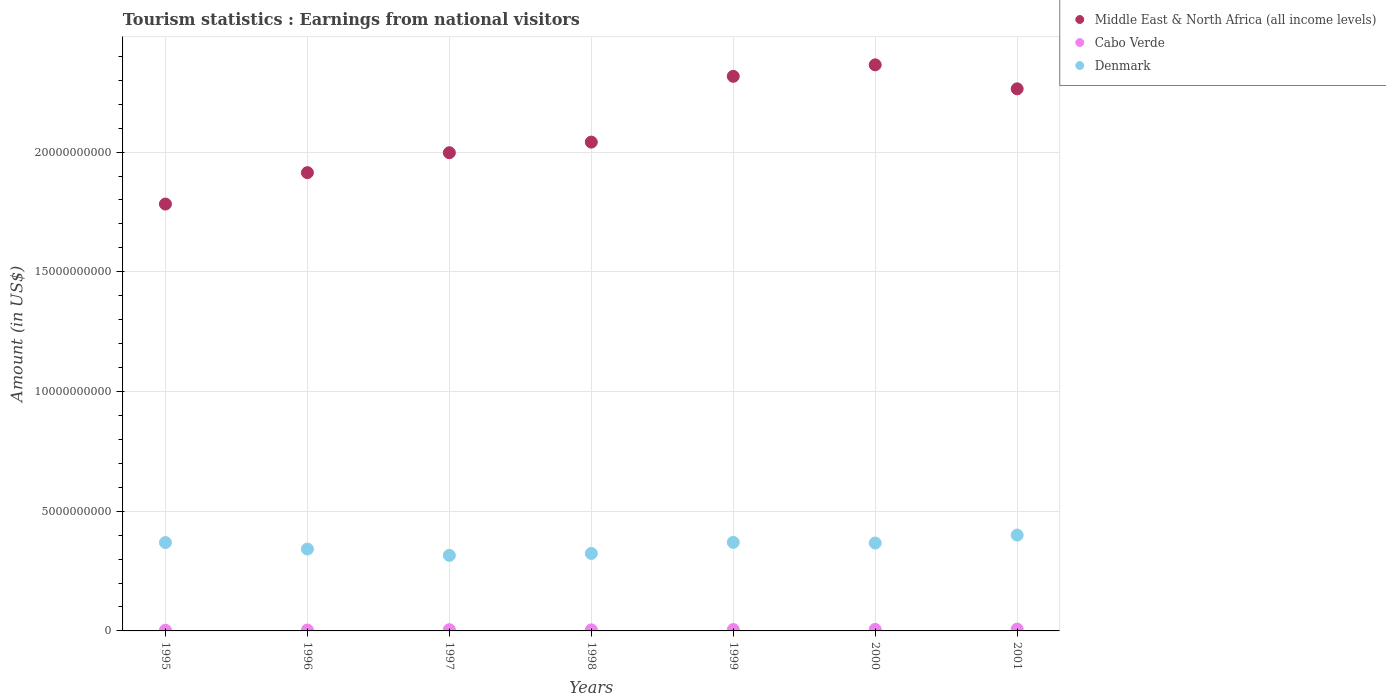How many different coloured dotlines are there?
Give a very brief answer. 3. Is the number of dotlines equal to the number of legend labels?
Your answer should be very brief. Yes. What is the earnings from national visitors in Denmark in 1996?
Offer a terse response. 3.42e+09. Across all years, what is the maximum earnings from national visitors in Cabo Verde?
Keep it short and to the point. 7.70e+07. Across all years, what is the minimum earnings from national visitors in Cabo Verde?
Your response must be concise. 2.90e+07. In which year was the earnings from national visitors in Cabo Verde minimum?
Your answer should be compact. 1995. What is the total earnings from national visitors in Cabo Verde in the graph?
Provide a short and direct response. 3.58e+08. What is the difference between the earnings from national visitors in Denmark in 1999 and that in 2000?
Your response must be concise. 2.70e+07. What is the difference between the earnings from national visitors in Cabo Verde in 1995 and the earnings from national visitors in Denmark in 2000?
Provide a succinct answer. -3.64e+09. What is the average earnings from national visitors in Denmark per year?
Your answer should be very brief. 3.55e+09. In the year 2001, what is the difference between the earnings from national visitors in Denmark and earnings from national visitors in Cabo Verde?
Your answer should be compact. 3.93e+09. What is the ratio of the earnings from national visitors in Cabo Verde in 1996 to that in 1998?
Provide a short and direct response. 0.82. Is the earnings from national visitors in Denmark in 1998 less than that in 1999?
Your answer should be very brief. Yes. What is the difference between the highest and the second highest earnings from national visitors in Denmark?
Your answer should be compact. 3.05e+08. What is the difference between the highest and the lowest earnings from national visitors in Cabo Verde?
Ensure brevity in your answer.  4.80e+07. Is it the case that in every year, the sum of the earnings from national visitors in Cabo Verde and earnings from national visitors in Middle East & North Africa (all income levels)  is greater than the earnings from national visitors in Denmark?
Offer a very short reply. Yes. Is the earnings from national visitors in Cabo Verde strictly less than the earnings from national visitors in Denmark over the years?
Make the answer very short. Yes. How many dotlines are there?
Ensure brevity in your answer.  3. How many years are there in the graph?
Make the answer very short. 7. Are the values on the major ticks of Y-axis written in scientific E-notation?
Ensure brevity in your answer.  No. What is the title of the graph?
Provide a succinct answer. Tourism statistics : Earnings from national visitors. Does "Trinidad and Tobago" appear as one of the legend labels in the graph?
Provide a short and direct response. No. What is the Amount (in US$) of Middle East & North Africa (all income levels) in 1995?
Offer a very short reply. 1.78e+1. What is the Amount (in US$) in Cabo Verde in 1995?
Provide a succinct answer. 2.90e+07. What is the Amount (in US$) of Denmark in 1995?
Make the answer very short. 3.69e+09. What is the Amount (in US$) in Middle East & North Africa (all income levels) in 1996?
Your answer should be compact. 1.91e+1. What is the Amount (in US$) of Cabo Verde in 1996?
Your answer should be very brief. 3.70e+07. What is the Amount (in US$) in Denmark in 1996?
Provide a succinct answer. 3.42e+09. What is the Amount (in US$) in Middle East & North Africa (all income levels) in 1997?
Your answer should be very brief. 2.00e+1. What is the Amount (in US$) in Cabo Verde in 1997?
Your answer should be very brief. 5.00e+07. What is the Amount (in US$) in Denmark in 1997?
Ensure brevity in your answer.  3.16e+09. What is the Amount (in US$) of Middle East & North Africa (all income levels) in 1998?
Offer a very short reply. 2.04e+1. What is the Amount (in US$) of Cabo Verde in 1998?
Keep it short and to the point. 4.50e+07. What is the Amount (in US$) in Denmark in 1998?
Provide a short and direct response. 3.24e+09. What is the Amount (in US$) in Middle East & North Africa (all income levels) in 1999?
Offer a terse response. 2.32e+1. What is the Amount (in US$) of Cabo Verde in 1999?
Offer a very short reply. 5.60e+07. What is the Amount (in US$) of Denmark in 1999?
Provide a succinct answer. 3.70e+09. What is the Amount (in US$) of Middle East & North Africa (all income levels) in 2000?
Offer a very short reply. 2.36e+1. What is the Amount (in US$) in Cabo Verde in 2000?
Offer a terse response. 6.40e+07. What is the Amount (in US$) of Denmark in 2000?
Make the answer very short. 3.67e+09. What is the Amount (in US$) in Middle East & North Africa (all income levels) in 2001?
Keep it short and to the point. 2.26e+1. What is the Amount (in US$) of Cabo Verde in 2001?
Give a very brief answer. 7.70e+07. What is the Amount (in US$) in Denmark in 2001?
Make the answer very short. 4.00e+09. Across all years, what is the maximum Amount (in US$) of Middle East & North Africa (all income levels)?
Give a very brief answer. 2.36e+1. Across all years, what is the maximum Amount (in US$) in Cabo Verde?
Give a very brief answer. 7.70e+07. Across all years, what is the maximum Amount (in US$) of Denmark?
Provide a short and direct response. 4.00e+09. Across all years, what is the minimum Amount (in US$) of Middle East & North Africa (all income levels)?
Your answer should be compact. 1.78e+1. Across all years, what is the minimum Amount (in US$) in Cabo Verde?
Your response must be concise. 2.90e+07. Across all years, what is the minimum Amount (in US$) of Denmark?
Make the answer very short. 3.16e+09. What is the total Amount (in US$) of Middle East & North Africa (all income levels) in the graph?
Provide a short and direct response. 1.47e+11. What is the total Amount (in US$) in Cabo Verde in the graph?
Keep it short and to the point. 3.58e+08. What is the total Amount (in US$) of Denmark in the graph?
Your answer should be very brief. 2.49e+1. What is the difference between the Amount (in US$) of Middle East & North Africa (all income levels) in 1995 and that in 1996?
Give a very brief answer. -1.31e+09. What is the difference between the Amount (in US$) of Cabo Verde in 1995 and that in 1996?
Provide a short and direct response. -8.00e+06. What is the difference between the Amount (in US$) of Denmark in 1995 and that in 1996?
Give a very brief answer. 2.71e+08. What is the difference between the Amount (in US$) in Middle East & North Africa (all income levels) in 1995 and that in 1997?
Your answer should be very brief. -2.14e+09. What is the difference between the Amount (in US$) in Cabo Verde in 1995 and that in 1997?
Offer a very short reply. -2.10e+07. What is the difference between the Amount (in US$) of Denmark in 1995 and that in 1997?
Give a very brief answer. 5.35e+08. What is the difference between the Amount (in US$) in Middle East & North Africa (all income levels) in 1995 and that in 1998?
Keep it short and to the point. -2.59e+09. What is the difference between the Amount (in US$) of Cabo Verde in 1995 and that in 1998?
Offer a very short reply. -1.60e+07. What is the difference between the Amount (in US$) in Denmark in 1995 and that in 1998?
Offer a very short reply. 4.55e+08. What is the difference between the Amount (in US$) of Middle East & North Africa (all income levels) in 1995 and that in 1999?
Provide a succinct answer. -5.34e+09. What is the difference between the Amount (in US$) in Cabo Verde in 1995 and that in 1999?
Give a very brief answer. -2.70e+07. What is the difference between the Amount (in US$) of Denmark in 1995 and that in 1999?
Ensure brevity in your answer.  -7.00e+06. What is the difference between the Amount (in US$) in Middle East & North Africa (all income levels) in 1995 and that in 2000?
Make the answer very short. -5.81e+09. What is the difference between the Amount (in US$) in Cabo Verde in 1995 and that in 2000?
Your answer should be very brief. -3.50e+07. What is the difference between the Amount (in US$) in Denmark in 1995 and that in 2000?
Provide a short and direct response. 2.00e+07. What is the difference between the Amount (in US$) in Middle East & North Africa (all income levels) in 1995 and that in 2001?
Ensure brevity in your answer.  -4.81e+09. What is the difference between the Amount (in US$) in Cabo Verde in 1995 and that in 2001?
Provide a succinct answer. -4.80e+07. What is the difference between the Amount (in US$) of Denmark in 1995 and that in 2001?
Offer a very short reply. -3.12e+08. What is the difference between the Amount (in US$) in Middle East & North Africa (all income levels) in 1996 and that in 1997?
Ensure brevity in your answer.  -8.33e+08. What is the difference between the Amount (in US$) in Cabo Verde in 1996 and that in 1997?
Provide a succinct answer. -1.30e+07. What is the difference between the Amount (in US$) in Denmark in 1996 and that in 1997?
Offer a terse response. 2.64e+08. What is the difference between the Amount (in US$) in Middle East & North Africa (all income levels) in 1996 and that in 1998?
Your response must be concise. -1.28e+09. What is the difference between the Amount (in US$) in Cabo Verde in 1996 and that in 1998?
Offer a very short reply. -8.00e+06. What is the difference between the Amount (in US$) in Denmark in 1996 and that in 1998?
Ensure brevity in your answer.  1.84e+08. What is the difference between the Amount (in US$) in Middle East & North Africa (all income levels) in 1996 and that in 1999?
Offer a very short reply. -4.02e+09. What is the difference between the Amount (in US$) in Cabo Verde in 1996 and that in 1999?
Keep it short and to the point. -1.90e+07. What is the difference between the Amount (in US$) of Denmark in 1996 and that in 1999?
Offer a terse response. -2.78e+08. What is the difference between the Amount (in US$) in Middle East & North Africa (all income levels) in 1996 and that in 2000?
Your answer should be very brief. -4.50e+09. What is the difference between the Amount (in US$) of Cabo Verde in 1996 and that in 2000?
Keep it short and to the point. -2.70e+07. What is the difference between the Amount (in US$) of Denmark in 1996 and that in 2000?
Provide a short and direct response. -2.51e+08. What is the difference between the Amount (in US$) in Middle East & North Africa (all income levels) in 1996 and that in 2001?
Offer a very short reply. -3.50e+09. What is the difference between the Amount (in US$) of Cabo Verde in 1996 and that in 2001?
Your response must be concise. -4.00e+07. What is the difference between the Amount (in US$) in Denmark in 1996 and that in 2001?
Your response must be concise. -5.83e+08. What is the difference between the Amount (in US$) in Middle East & North Africa (all income levels) in 1997 and that in 1998?
Make the answer very short. -4.43e+08. What is the difference between the Amount (in US$) of Denmark in 1997 and that in 1998?
Give a very brief answer. -8.00e+07. What is the difference between the Amount (in US$) in Middle East & North Africa (all income levels) in 1997 and that in 1999?
Provide a succinct answer. -3.19e+09. What is the difference between the Amount (in US$) of Cabo Verde in 1997 and that in 1999?
Your answer should be compact. -6.00e+06. What is the difference between the Amount (in US$) of Denmark in 1997 and that in 1999?
Offer a terse response. -5.42e+08. What is the difference between the Amount (in US$) in Middle East & North Africa (all income levels) in 1997 and that in 2000?
Offer a terse response. -3.67e+09. What is the difference between the Amount (in US$) in Cabo Verde in 1997 and that in 2000?
Provide a succinct answer. -1.40e+07. What is the difference between the Amount (in US$) in Denmark in 1997 and that in 2000?
Provide a short and direct response. -5.15e+08. What is the difference between the Amount (in US$) in Middle East & North Africa (all income levels) in 1997 and that in 2001?
Ensure brevity in your answer.  -2.67e+09. What is the difference between the Amount (in US$) of Cabo Verde in 1997 and that in 2001?
Your response must be concise. -2.70e+07. What is the difference between the Amount (in US$) of Denmark in 1997 and that in 2001?
Give a very brief answer. -8.47e+08. What is the difference between the Amount (in US$) of Middle East & North Africa (all income levels) in 1998 and that in 1999?
Provide a short and direct response. -2.75e+09. What is the difference between the Amount (in US$) of Cabo Verde in 1998 and that in 1999?
Your answer should be very brief. -1.10e+07. What is the difference between the Amount (in US$) of Denmark in 1998 and that in 1999?
Make the answer very short. -4.62e+08. What is the difference between the Amount (in US$) of Middle East & North Africa (all income levels) in 1998 and that in 2000?
Offer a very short reply. -3.23e+09. What is the difference between the Amount (in US$) of Cabo Verde in 1998 and that in 2000?
Keep it short and to the point. -1.90e+07. What is the difference between the Amount (in US$) of Denmark in 1998 and that in 2000?
Your answer should be very brief. -4.35e+08. What is the difference between the Amount (in US$) of Middle East & North Africa (all income levels) in 1998 and that in 2001?
Offer a terse response. -2.22e+09. What is the difference between the Amount (in US$) of Cabo Verde in 1998 and that in 2001?
Provide a short and direct response. -3.20e+07. What is the difference between the Amount (in US$) in Denmark in 1998 and that in 2001?
Make the answer very short. -7.67e+08. What is the difference between the Amount (in US$) of Middle East & North Africa (all income levels) in 1999 and that in 2000?
Offer a very short reply. -4.79e+08. What is the difference between the Amount (in US$) in Cabo Verde in 1999 and that in 2000?
Give a very brief answer. -8.00e+06. What is the difference between the Amount (in US$) in Denmark in 1999 and that in 2000?
Make the answer very short. 2.70e+07. What is the difference between the Amount (in US$) of Middle East & North Africa (all income levels) in 1999 and that in 2001?
Your answer should be compact. 5.23e+08. What is the difference between the Amount (in US$) of Cabo Verde in 1999 and that in 2001?
Provide a succinct answer. -2.10e+07. What is the difference between the Amount (in US$) in Denmark in 1999 and that in 2001?
Give a very brief answer. -3.05e+08. What is the difference between the Amount (in US$) of Middle East & North Africa (all income levels) in 2000 and that in 2001?
Provide a succinct answer. 1.00e+09. What is the difference between the Amount (in US$) of Cabo Verde in 2000 and that in 2001?
Keep it short and to the point. -1.30e+07. What is the difference between the Amount (in US$) in Denmark in 2000 and that in 2001?
Your response must be concise. -3.32e+08. What is the difference between the Amount (in US$) in Middle East & North Africa (all income levels) in 1995 and the Amount (in US$) in Cabo Verde in 1996?
Offer a very short reply. 1.78e+1. What is the difference between the Amount (in US$) in Middle East & North Africa (all income levels) in 1995 and the Amount (in US$) in Denmark in 1996?
Make the answer very short. 1.44e+1. What is the difference between the Amount (in US$) of Cabo Verde in 1995 and the Amount (in US$) of Denmark in 1996?
Offer a terse response. -3.39e+09. What is the difference between the Amount (in US$) in Middle East & North Africa (all income levels) in 1995 and the Amount (in US$) in Cabo Verde in 1997?
Give a very brief answer. 1.78e+1. What is the difference between the Amount (in US$) of Middle East & North Africa (all income levels) in 1995 and the Amount (in US$) of Denmark in 1997?
Provide a short and direct response. 1.47e+1. What is the difference between the Amount (in US$) in Cabo Verde in 1995 and the Amount (in US$) in Denmark in 1997?
Your answer should be compact. -3.13e+09. What is the difference between the Amount (in US$) of Middle East & North Africa (all income levels) in 1995 and the Amount (in US$) of Cabo Verde in 1998?
Offer a terse response. 1.78e+1. What is the difference between the Amount (in US$) in Middle East & North Africa (all income levels) in 1995 and the Amount (in US$) in Denmark in 1998?
Offer a very short reply. 1.46e+1. What is the difference between the Amount (in US$) in Cabo Verde in 1995 and the Amount (in US$) in Denmark in 1998?
Your answer should be very brief. -3.21e+09. What is the difference between the Amount (in US$) in Middle East & North Africa (all income levels) in 1995 and the Amount (in US$) in Cabo Verde in 1999?
Keep it short and to the point. 1.78e+1. What is the difference between the Amount (in US$) in Middle East & North Africa (all income levels) in 1995 and the Amount (in US$) in Denmark in 1999?
Keep it short and to the point. 1.41e+1. What is the difference between the Amount (in US$) of Cabo Verde in 1995 and the Amount (in US$) of Denmark in 1999?
Make the answer very short. -3.67e+09. What is the difference between the Amount (in US$) of Middle East & North Africa (all income levels) in 1995 and the Amount (in US$) of Cabo Verde in 2000?
Keep it short and to the point. 1.78e+1. What is the difference between the Amount (in US$) in Middle East & North Africa (all income levels) in 1995 and the Amount (in US$) in Denmark in 2000?
Make the answer very short. 1.42e+1. What is the difference between the Amount (in US$) of Cabo Verde in 1995 and the Amount (in US$) of Denmark in 2000?
Your answer should be compact. -3.64e+09. What is the difference between the Amount (in US$) of Middle East & North Africa (all income levels) in 1995 and the Amount (in US$) of Cabo Verde in 2001?
Your response must be concise. 1.78e+1. What is the difference between the Amount (in US$) in Middle East & North Africa (all income levels) in 1995 and the Amount (in US$) in Denmark in 2001?
Provide a succinct answer. 1.38e+1. What is the difference between the Amount (in US$) in Cabo Verde in 1995 and the Amount (in US$) in Denmark in 2001?
Your answer should be very brief. -3.97e+09. What is the difference between the Amount (in US$) of Middle East & North Africa (all income levels) in 1996 and the Amount (in US$) of Cabo Verde in 1997?
Make the answer very short. 1.91e+1. What is the difference between the Amount (in US$) of Middle East & North Africa (all income levels) in 1996 and the Amount (in US$) of Denmark in 1997?
Your answer should be very brief. 1.60e+1. What is the difference between the Amount (in US$) of Cabo Verde in 1996 and the Amount (in US$) of Denmark in 1997?
Make the answer very short. -3.12e+09. What is the difference between the Amount (in US$) in Middle East & North Africa (all income levels) in 1996 and the Amount (in US$) in Cabo Verde in 1998?
Make the answer very short. 1.91e+1. What is the difference between the Amount (in US$) in Middle East & North Africa (all income levels) in 1996 and the Amount (in US$) in Denmark in 1998?
Give a very brief answer. 1.59e+1. What is the difference between the Amount (in US$) of Cabo Verde in 1996 and the Amount (in US$) of Denmark in 1998?
Your answer should be very brief. -3.20e+09. What is the difference between the Amount (in US$) in Middle East & North Africa (all income levels) in 1996 and the Amount (in US$) in Cabo Verde in 1999?
Keep it short and to the point. 1.91e+1. What is the difference between the Amount (in US$) in Middle East & North Africa (all income levels) in 1996 and the Amount (in US$) in Denmark in 1999?
Your answer should be compact. 1.54e+1. What is the difference between the Amount (in US$) in Cabo Verde in 1996 and the Amount (in US$) in Denmark in 1999?
Offer a very short reply. -3.66e+09. What is the difference between the Amount (in US$) of Middle East & North Africa (all income levels) in 1996 and the Amount (in US$) of Cabo Verde in 2000?
Your answer should be very brief. 1.91e+1. What is the difference between the Amount (in US$) in Middle East & North Africa (all income levels) in 1996 and the Amount (in US$) in Denmark in 2000?
Provide a short and direct response. 1.55e+1. What is the difference between the Amount (in US$) of Cabo Verde in 1996 and the Amount (in US$) of Denmark in 2000?
Your response must be concise. -3.63e+09. What is the difference between the Amount (in US$) of Middle East & North Africa (all income levels) in 1996 and the Amount (in US$) of Cabo Verde in 2001?
Keep it short and to the point. 1.91e+1. What is the difference between the Amount (in US$) in Middle East & North Africa (all income levels) in 1996 and the Amount (in US$) in Denmark in 2001?
Provide a short and direct response. 1.51e+1. What is the difference between the Amount (in US$) in Cabo Verde in 1996 and the Amount (in US$) in Denmark in 2001?
Your answer should be very brief. -3.97e+09. What is the difference between the Amount (in US$) of Middle East & North Africa (all income levels) in 1997 and the Amount (in US$) of Cabo Verde in 1998?
Offer a terse response. 1.99e+1. What is the difference between the Amount (in US$) in Middle East & North Africa (all income levels) in 1997 and the Amount (in US$) in Denmark in 1998?
Provide a succinct answer. 1.67e+1. What is the difference between the Amount (in US$) in Cabo Verde in 1997 and the Amount (in US$) in Denmark in 1998?
Offer a terse response. -3.19e+09. What is the difference between the Amount (in US$) in Middle East & North Africa (all income levels) in 1997 and the Amount (in US$) in Cabo Verde in 1999?
Provide a succinct answer. 1.99e+1. What is the difference between the Amount (in US$) of Middle East & North Africa (all income levels) in 1997 and the Amount (in US$) of Denmark in 1999?
Provide a short and direct response. 1.63e+1. What is the difference between the Amount (in US$) in Cabo Verde in 1997 and the Amount (in US$) in Denmark in 1999?
Make the answer very short. -3.65e+09. What is the difference between the Amount (in US$) of Middle East & North Africa (all income levels) in 1997 and the Amount (in US$) of Cabo Verde in 2000?
Your answer should be compact. 1.99e+1. What is the difference between the Amount (in US$) of Middle East & North Africa (all income levels) in 1997 and the Amount (in US$) of Denmark in 2000?
Ensure brevity in your answer.  1.63e+1. What is the difference between the Amount (in US$) of Cabo Verde in 1997 and the Amount (in US$) of Denmark in 2000?
Offer a very short reply. -3.62e+09. What is the difference between the Amount (in US$) in Middle East & North Africa (all income levels) in 1997 and the Amount (in US$) in Cabo Verde in 2001?
Your answer should be compact. 1.99e+1. What is the difference between the Amount (in US$) of Middle East & North Africa (all income levels) in 1997 and the Amount (in US$) of Denmark in 2001?
Offer a terse response. 1.60e+1. What is the difference between the Amount (in US$) in Cabo Verde in 1997 and the Amount (in US$) in Denmark in 2001?
Your answer should be very brief. -3.95e+09. What is the difference between the Amount (in US$) of Middle East & North Africa (all income levels) in 1998 and the Amount (in US$) of Cabo Verde in 1999?
Your answer should be very brief. 2.04e+1. What is the difference between the Amount (in US$) of Middle East & North Africa (all income levels) in 1998 and the Amount (in US$) of Denmark in 1999?
Give a very brief answer. 1.67e+1. What is the difference between the Amount (in US$) in Cabo Verde in 1998 and the Amount (in US$) in Denmark in 1999?
Offer a very short reply. -3.65e+09. What is the difference between the Amount (in US$) of Middle East & North Africa (all income levels) in 1998 and the Amount (in US$) of Cabo Verde in 2000?
Your answer should be very brief. 2.04e+1. What is the difference between the Amount (in US$) in Middle East & North Africa (all income levels) in 1998 and the Amount (in US$) in Denmark in 2000?
Provide a short and direct response. 1.67e+1. What is the difference between the Amount (in US$) of Cabo Verde in 1998 and the Amount (in US$) of Denmark in 2000?
Your answer should be very brief. -3.63e+09. What is the difference between the Amount (in US$) of Middle East & North Africa (all income levels) in 1998 and the Amount (in US$) of Cabo Verde in 2001?
Offer a terse response. 2.03e+1. What is the difference between the Amount (in US$) of Middle East & North Africa (all income levels) in 1998 and the Amount (in US$) of Denmark in 2001?
Offer a terse response. 1.64e+1. What is the difference between the Amount (in US$) of Cabo Verde in 1998 and the Amount (in US$) of Denmark in 2001?
Your answer should be very brief. -3.96e+09. What is the difference between the Amount (in US$) of Middle East & North Africa (all income levels) in 1999 and the Amount (in US$) of Cabo Verde in 2000?
Your answer should be compact. 2.31e+1. What is the difference between the Amount (in US$) in Middle East & North Africa (all income levels) in 1999 and the Amount (in US$) in Denmark in 2000?
Your response must be concise. 1.95e+1. What is the difference between the Amount (in US$) in Cabo Verde in 1999 and the Amount (in US$) in Denmark in 2000?
Provide a succinct answer. -3.62e+09. What is the difference between the Amount (in US$) in Middle East & North Africa (all income levels) in 1999 and the Amount (in US$) in Cabo Verde in 2001?
Provide a succinct answer. 2.31e+1. What is the difference between the Amount (in US$) of Middle East & North Africa (all income levels) in 1999 and the Amount (in US$) of Denmark in 2001?
Offer a very short reply. 1.92e+1. What is the difference between the Amount (in US$) of Cabo Verde in 1999 and the Amount (in US$) of Denmark in 2001?
Your response must be concise. -3.95e+09. What is the difference between the Amount (in US$) of Middle East & North Africa (all income levels) in 2000 and the Amount (in US$) of Cabo Verde in 2001?
Your answer should be very brief. 2.36e+1. What is the difference between the Amount (in US$) in Middle East & North Africa (all income levels) in 2000 and the Amount (in US$) in Denmark in 2001?
Provide a short and direct response. 1.96e+1. What is the difference between the Amount (in US$) in Cabo Verde in 2000 and the Amount (in US$) in Denmark in 2001?
Ensure brevity in your answer.  -3.94e+09. What is the average Amount (in US$) of Middle East & North Africa (all income levels) per year?
Your answer should be very brief. 2.10e+1. What is the average Amount (in US$) in Cabo Verde per year?
Offer a terse response. 5.11e+07. What is the average Amount (in US$) of Denmark per year?
Your response must be concise. 3.55e+09. In the year 1995, what is the difference between the Amount (in US$) of Middle East & North Africa (all income levels) and Amount (in US$) of Cabo Verde?
Offer a very short reply. 1.78e+1. In the year 1995, what is the difference between the Amount (in US$) of Middle East & North Africa (all income levels) and Amount (in US$) of Denmark?
Keep it short and to the point. 1.41e+1. In the year 1995, what is the difference between the Amount (in US$) of Cabo Verde and Amount (in US$) of Denmark?
Your response must be concise. -3.66e+09. In the year 1996, what is the difference between the Amount (in US$) in Middle East & North Africa (all income levels) and Amount (in US$) in Cabo Verde?
Give a very brief answer. 1.91e+1. In the year 1996, what is the difference between the Amount (in US$) in Middle East & North Africa (all income levels) and Amount (in US$) in Denmark?
Provide a short and direct response. 1.57e+1. In the year 1996, what is the difference between the Amount (in US$) in Cabo Verde and Amount (in US$) in Denmark?
Provide a short and direct response. -3.38e+09. In the year 1997, what is the difference between the Amount (in US$) in Middle East & North Africa (all income levels) and Amount (in US$) in Cabo Verde?
Provide a short and direct response. 1.99e+1. In the year 1997, what is the difference between the Amount (in US$) of Middle East & North Africa (all income levels) and Amount (in US$) of Denmark?
Ensure brevity in your answer.  1.68e+1. In the year 1997, what is the difference between the Amount (in US$) of Cabo Verde and Amount (in US$) of Denmark?
Provide a short and direct response. -3.11e+09. In the year 1998, what is the difference between the Amount (in US$) of Middle East & North Africa (all income levels) and Amount (in US$) of Cabo Verde?
Provide a short and direct response. 2.04e+1. In the year 1998, what is the difference between the Amount (in US$) in Middle East & North Africa (all income levels) and Amount (in US$) in Denmark?
Provide a succinct answer. 1.72e+1. In the year 1998, what is the difference between the Amount (in US$) in Cabo Verde and Amount (in US$) in Denmark?
Give a very brief answer. -3.19e+09. In the year 1999, what is the difference between the Amount (in US$) in Middle East & North Africa (all income levels) and Amount (in US$) in Cabo Verde?
Your answer should be compact. 2.31e+1. In the year 1999, what is the difference between the Amount (in US$) of Middle East & North Africa (all income levels) and Amount (in US$) of Denmark?
Your answer should be very brief. 1.95e+1. In the year 1999, what is the difference between the Amount (in US$) in Cabo Verde and Amount (in US$) in Denmark?
Your answer should be very brief. -3.64e+09. In the year 2000, what is the difference between the Amount (in US$) in Middle East & North Africa (all income levels) and Amount (in US$) in Cabo Verde?
Make the answer very short. 2.36e+1. In the year 2000, what is the difference between the Amount (in US$) in Middle East & North Africa (all income levels) and Amount (in US$) in Denmark?
Offer a very short reply. 2.00e+1. In the year 2000, what is the difference between the Amount (in US$) in Cabo Verde and Amount (in US$) in Denmark?
Make the answer very short. -3.61e+09. In the year 2001, what is the difference between the Amount (in US$) in Middle East & North Africa (all income levels) and Amount (in US$) in Cabo Verde?
Offer a terse response. 2.26e+1. In the year 2001, what is the difference between the Amount (in US$) in Middle East & North Africa (all income levels) and Amount (in US$) in Denmark?
Your answer should be very brief. 1.86e+1. In the year 2001, what is the difference between the Amount (in US$) in Cabo Verde and Amount (in US$) in Denmark?
Offer a very short reply. -3.93e+09. What is the ratio of the Amount (in US$) of Middle East & North Africa (all income levels) in 1995 to that in 1996?
Keep it short and to the point. 0.93. What is the ratio of the Amount (in US$) in Cabo Verde in 1995 to that in 1996?
Offer a very short reply. 0.78. What is the ratio of the Amount (in US$) in Denmark in 1995 to that in 1996?
Give a very brief answer. 1.08. What is the ratio of the Amount (in US$) in Middle East & North Africa (all income levels) in 1995 to that in 1997?
Make the answer very short. 0.89. What is the ratio of the Amount (in US$) of Cabo Verde in 1995 to that in 1997?
Provide a succinct answer. 0.58. What is the ratio of the Amount (in US$) in Denmark in 1995 to that in 1997?
Your answer should be very brief. 1.17. What is the ratio of the Amount (in US$) of Middle East & North Africa (all income levels) in 1995 to that in 1998?
Your answer should be compact. 0.87. What is the ratio of the Amount (in US$) in Cabo Verde in 1995 to that in 1998?
Provide a short and direct response. 0.64. What is the ratio of the Amount (in US$) of Denmark in 1995 to that in 1998?
Your answer should be compact. 1.14. What is the ratio of the Amount (in US$) in Middle East & North Africa (all income levels) in 1995 to that in 1999?
Ensure brevity in your answer.  0.77. What is the ratio of the Amount (in US$) in Cabo Verde in 1995 to that in 1999?
Keep it short and to the point. 0.52. What is the ratio of the Amount (in US$) in Denmark in 1995 to that in 1999?
Give a very brief answer. 1. What is the ratio of the Amount (in US$) of Middle East & North Africa (all income levels) in 1995 to that in 2000?
Offer a very short reply. 0.75. What is the ratio of the Amount (in US$) of Cabo Verde in 1995 to that in 2000?
Provide a short and direct response. 0.45. What is the ratio of the Amount (in US$) of Denmark in 1995 to that in 2000?
Make the answer very short. 1.01. What is the ratio of the Amount (in US$) of Middle East & North Africa (all income levels) in 1995 to that in 2001?
Offer a terse response. 0.79. What is the ratio of the Amount (in US$) of Cabo Verde in 1995 to that in 2001?
Your answer should be very brief. 0.38. What is the ratio of the Amount (in US$) of Denmark in 1995 to that in 2001?
Your answer should be compact. 0.92. What is the ratio of the Amount (in US$) of Middle East & North Africa (all income levels) in 1996 to that in 1997?
Offer a terse response. 0.96. What is the ratio of the Amount (in US$) of Cabo Verde in 1996 to that in 1997?
Your response must be concise. 0.74. What is the ratio of the Amount (in US$) of Denmark in 1996 to that in 1997?
Your response must be concise. 1.08. What is the ratio of the Amount (in US$) in Middle East & North Africa (all income levels) in 1996 to that in 1998?
Offer a terse response. 0.94. What is the ratio of the Amount (in US$) of Cabo Verde in 1996 to that in 1998?
Provide a succinct answer. 0.82. What is the ratio of the Amount (in US$) of Denmark in 1996 to that in 1998?
Provide a succinct answer. 1.06. What is the ratio of the Amount (in US$) in Middle East & North Africa (all income levels) in 1996 to that in 1999?
Provide a short and direct response. 0.83. What is the ratio of the Amount (in US$) in Cabo Verde in 1996 to that in 1999?
Your answer should be very brief. 0.66. What is the ratio of the Amount (in US$) in Denmark in 1996 to that in 1999?
Offer a very short reply. 0.92. What is the ratio of the Amount (in US$) of Middle East & North Africa (all income levels) in 1996 to that in 2000?
Your answer should be very brief. 0.81. What is the ratio of the Amount (in US$) in Cabo Verde in 1996 to that in 2000?
Give a very brief answer. 0.58. What is the ratio of the Amount (in US$) of Denmark in 1996 to that in 2000?
Provide a short and direct response. 0.93. What is the ratio of the Amount (in US$) in Middle East & North Africa (all income levels) in 1996 to that in 2001?
Make the answer very short. 0.85. What is the ratio of the Amount (in US$) of Cabo Verde in 1996 to that in 2001?
Your response must be concise. 0.48. What is the ratio of the Amount (in US$) of Denmark in 1996 to that in 2001?
Keep it short and to the point. 0.85. What is the ratio of the Amount (in US$) in Middle East & North Africa (all income levels) in 1997 to that in 1998?
Give a very brief answer. 0.98. What is the ratio of the Amount (in US$) of Cabo Verde in 1997 to that in 1998?
Your answer should be very brief. 1.11. What is the ratio of the Amount (in US$) in Denmark in 1997 to that in 1998?
Your response must be concise. 0.98. What is the ratio of the Amount (in US$) in Middle East & North Africa (all income levels) in 1997 to that in 1999?
Ensure brevity in your answer.  0.86. What is the ratio of the Amount (in US$) of Cabo Verde in 1997 to that in 1999?
Offer a terse response. 0.89. What is the ratio of the Amount (in US$) of Denmark in 1997 to that in 1999?
Give a very brief answer. 0.85. What is the ratio of the Amount (in US$) in Middle East & North Africa (all income levels) in 1997 to that in 2000?
Ensure brevity in your answer.  0.84. What is the ratio of the Amount (in US$) of Cabo Verde in 1997 to that in 2000?
Make the answer very short. 0.78. What is the ratio of the Amount (in US$) of Denmark in 1997 to that in 2000?
Your answer should be very brief. 0.86. What is the ratio of the Amount (in US$) in Middle East & North Africa (all income levels) in 1997 to that in 2001?
Provide a short and direct response. 0.88. What is the ratio of the Amount (in US$) in Cabo Verde in 1997 to that in 2001?
Your response must be concise. 0.65. What is the ratio of the Amount (in US$) in Denmark in 1997 to that in 2001?
Offer a very short reply. 0.79. What is the ratio of the Amount (in US$) in Middle East & North Africa (all income levels) in 1998 to that in 1999?
Your answer should be compact. 0.88. What is the ratio of the Amount (in US$) of Cabo Verde in 1998 to that in 1999?
Provide a short and direct response. 0.8. What is the ratio of the Amount (in US$) of Denmark in 1998 to that in 1999?
Your response must be concise. 0.88. What is the ratio of the Amount (in US$) in Middle East & North Africa (all income levels) in 1998 to that in 2000?
Offer a terse response. 0.86. What is the ratio of the Amount (in US$) in Cabo Verde in 1998 to that in 2000?
Your response must be concise. 0.7. What is the ratio of the Amount (in US$) of Denmark in 1998 to that in 2000?
Provide a succinct answer. 0.88. What is the ratio of the Amount (in US$) in Middle East & North Africa (all income levels) in 1998 to that in 2001?
Provide a succinct answer. 0.9. What is the ratio of the Amount (in US$) of Cabo Verde in 1998 to that in 2001?
Your answer should be very brief. 0.58. What is the ratio of the Amount (in US$) of Denmark in 1998 to that in 2001?
Offer a very short reply. 0.81. What is the ratio of the Amount (in US$) of Middle East & North Africa (all income levels) in 1999 to that in 2000?
Provide a short and direct response. 0.98. What is the ratio of the Amount (in US$) in Denmark in 1999 to that in 2000?
Make the answer very short. 1.01. What is the ratio of the Amount (in US$) in Middle East & North Africa (all income levels) in 1999 to that in 2001?
Your response must be concise. 1.02. What is the ratio of the Amount (in US$) of Cabo Verde in 1999 to that in 2001?
Provide a short and direct response. 0.73. What is the ratio of the Amount (in US$) of Denmark in 1999 to that in 2001?
Your response must be concise. 0.92. What is the ratio of the Amount (in US$) in Middle East & North Africa (all income levels) in 2000 to that in 2001?
Provide a succinct answer. 1.04. What is the ratio of the Amount (in US$) of Cabo Verde in 2000 to that in 2001?
Provide a succinct answer. 0.83. What is the ratio of the Amount (in US$) in Denmark in 2000 to that in 2001?
Keep it short and to the point. 0.92. What is the difference between the highest and the second highest Amount (in US$) of Middle East & North Africa (all income levels)?
Your answer should be compact. 4.79e+08. What is the difference between the highest and the second highest Amount (in US$) of Cabo Verde?
Give a very brief answer. 1.30e+07. What is the difference between the highest and the second highest Amount (in US$) of Denmark?
Your answer should be compact. 3.05e+08. What is the difference between the highest and the lowest Amount (in US$) of Middle East & North Africa (all income levels)?
Keep it short and to the point. 5.81e+09. What is the difference between the highest and the lowest Amount (in US$) in Cabo Verde?
Offer a terse response. 4.80e+07. What is the difference between the highest and the lowest Amount (in US$) of Denmark?
Your answer should be very brief. 8.47e+08. 